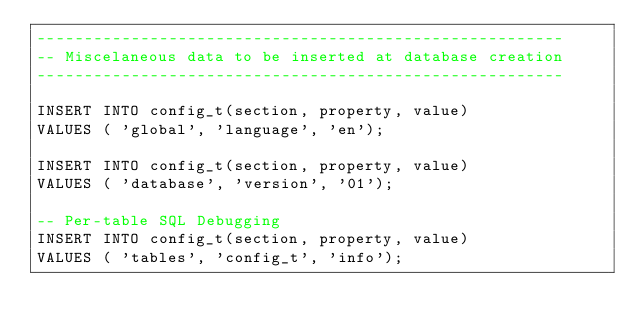<code> <loc_0><loc_0><loc_500><loc_500><_SQL_>--------------------------------------------------------
-- Miscelaneous data to be inserted at database creation
--------------------------------------------------------

INSERT INTO config_t(section, property, value) 
VALUES ( 'global', 'language', 'en');

INSERT INTO config_t(section, property, value) 
VALUES ( 'database', 'version', '01');

-- Per-table SQL Debugging
INSERT INTO config_t(section, property, value) 
VALUES ( 'tables', 'config_t', 'info');
</code> 